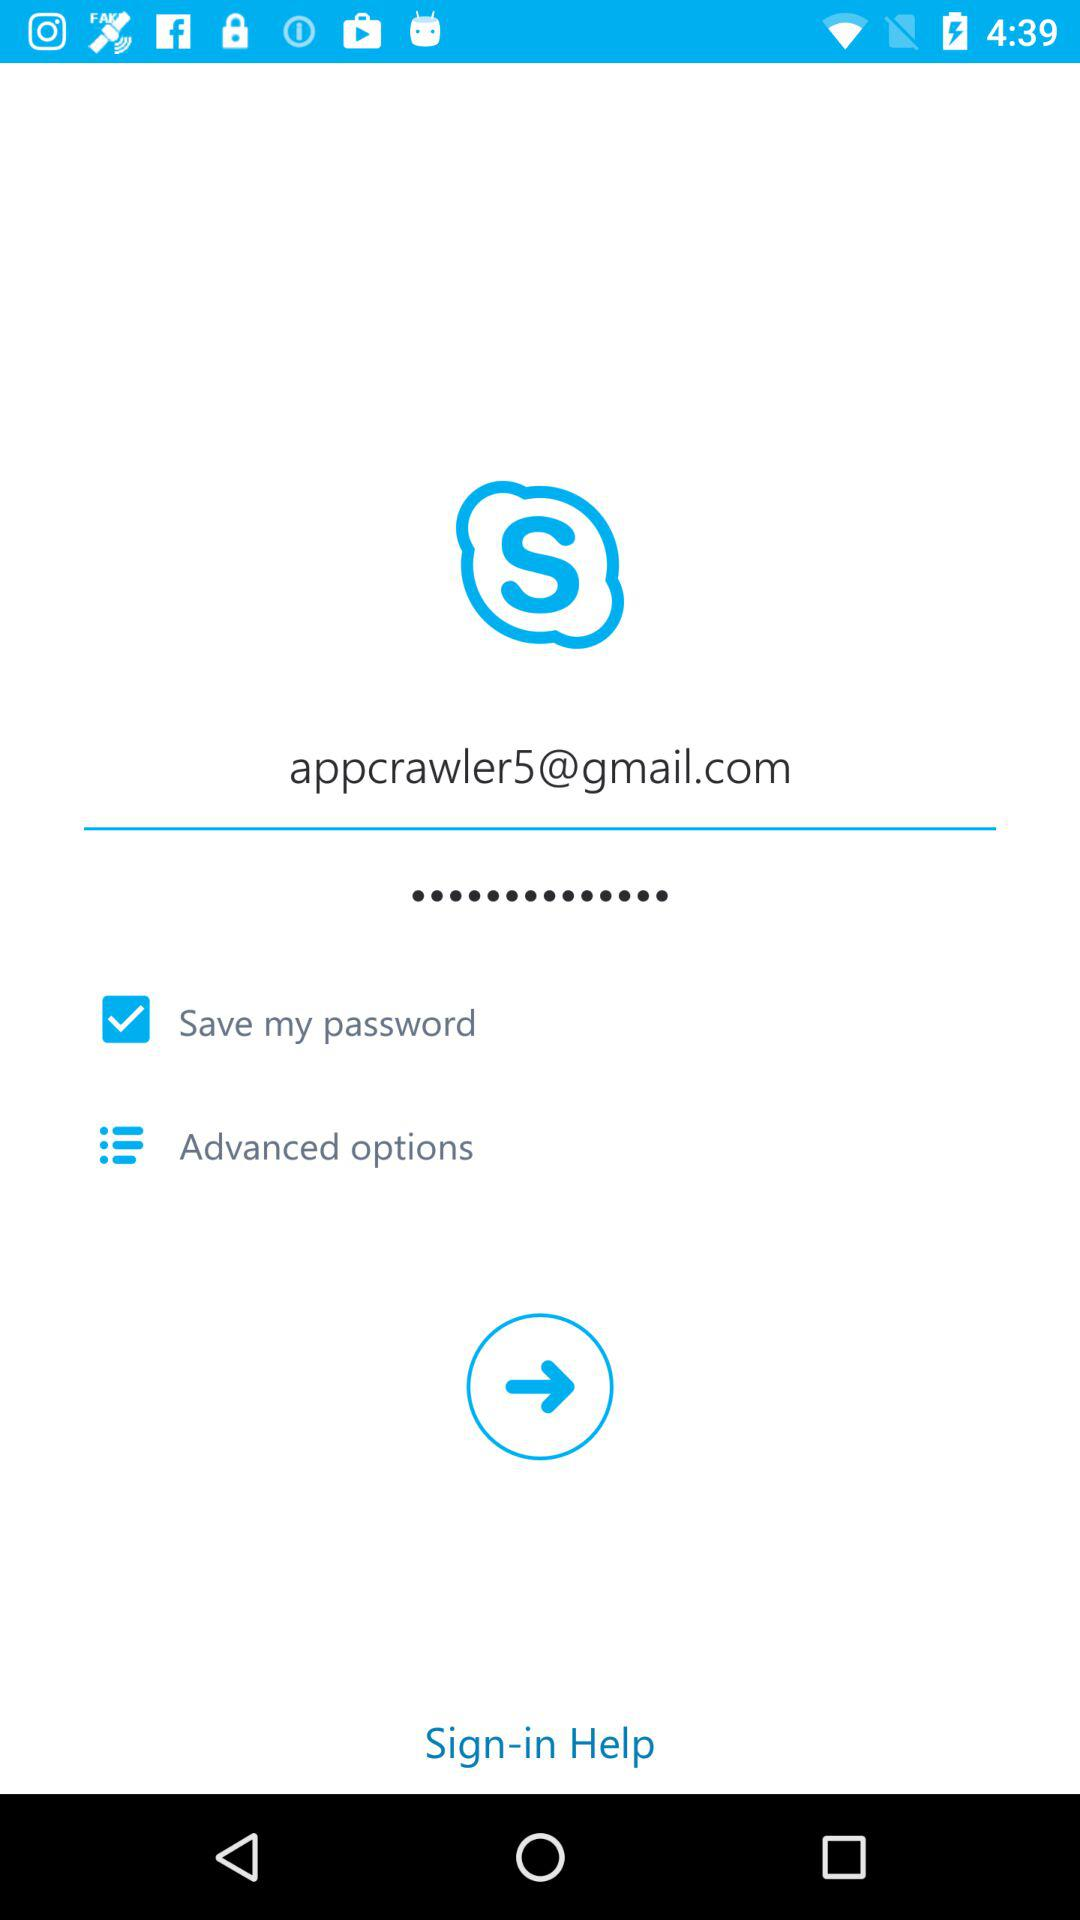What is the email address? The email address is appcrawler5@gmail.com. 